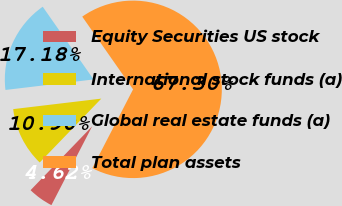Convert chart. <chart><loc_0><loc_0><loc_500><loc_500><pie_chart><fcel>Equity Securities US stock<fcel>International stock funds (a)<fcel>Global real estate funds (a)<fcel>Total plan assets<nl><fcel>4.62%<fcel>10.9%<fcel>17.18%<fcel>67.31%<nl></chart> 